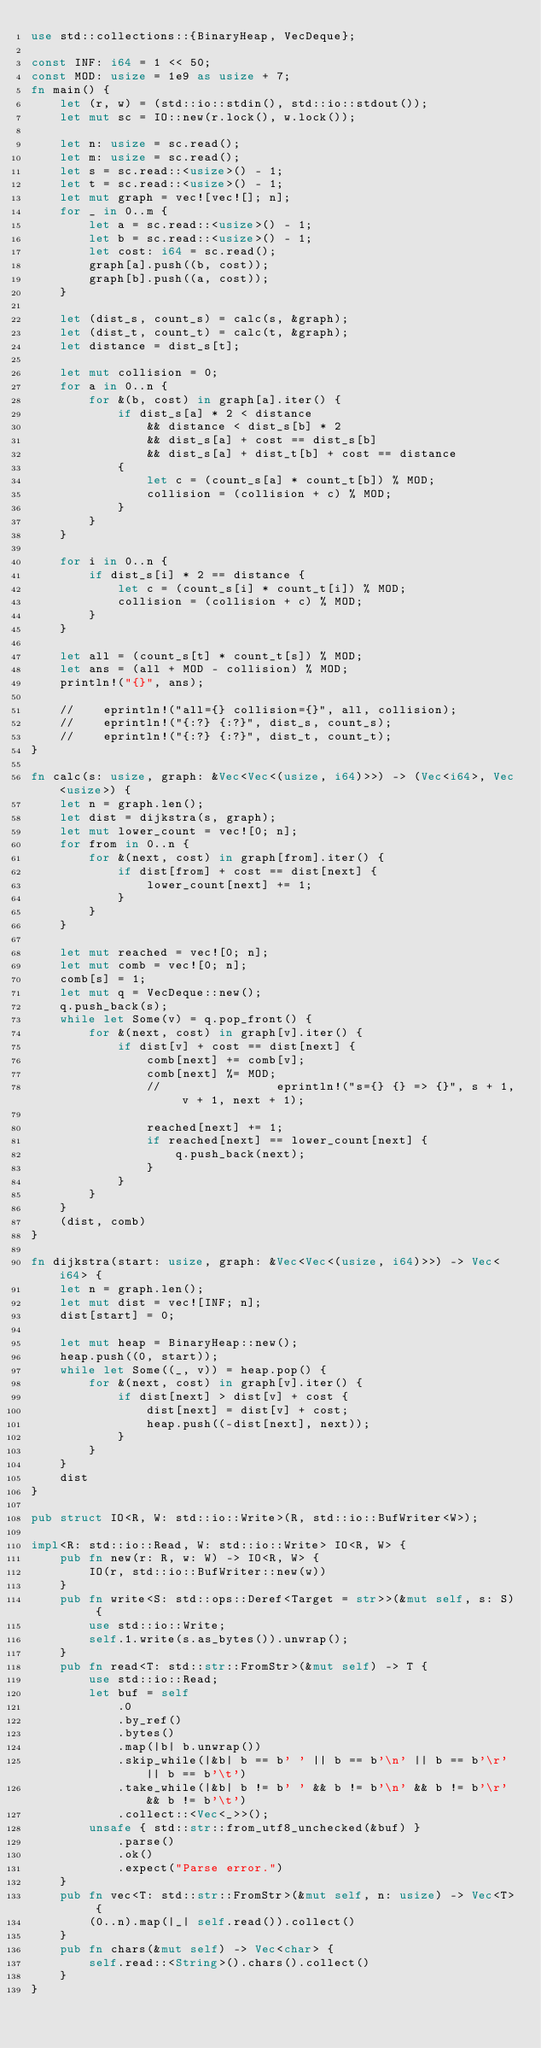<code> <loc_0><loc_0><loc_500><loc_500><_Rust_>use std::collections::{BinaryHeap, VecDeque};

const INF: i64 = 1 << 50;
const MOD: usize = 1e9 as usize + 7;
fn main() {
    let (r, w) = (std::io::stdin(), std::io::stdout());
    let mut sc = IO::new(r.lock(), w.lock());

    let n: usize = sc.read();
    let m: usize = sc.read();
    let s = sc.read::<usize>() - 1;
    let t = sc.read::<usize>() - 1;
    let mut graph = vec![vec![]; n];
    for _ in 0..m {
        let a = sc.read::<usize>() - 1;
        let b = sc.read::<usize>() - 1;
        let cost: i64 = sc.read();
        graph[a].push((b, cost));
        graph[b].push((a, cost));
    }

    let (dist_s, count_s) = calc(s, &graph);
    let (dist_t, count_t) = calc(t, &graph);
    let distance = dist_s[t];

    let mut collision = 0;
    for a in 0..n {
        for &(b, cost) in graph[a].iter() {
            if dist_s[a] * 2 < distance
                && distance < dist_s[b] * 2
                && dist_s[a] + cost == dist_s[b]
                && dist_s[a] + dist_t[b] + cost == distance
            {
                let c = (count_s[a] * count_t[b]) % MOD;
                collision = (collision + c) % MOD;
            }
        }
    }

    for i in 0..n {
        if dist_s[i] * 2 == distance {
            let c = (count_s[i] * count_t[i]) % MOD;
            collision = (collision + c) % MOD;
        }
    }

    let all = (count_s[t] * count_t[s]) % MOD;
    let ans = (all + MOD - collision) % MOD;
    println!("{}", ans);

    //    eprintln!("all={} collision={}", all, collision);
    //    eprintln!("{:?} {:?}", dist_s, count_s);
    //    eprintln!("{:?} {:?}", dist_t, count_t);
}

fn calc(s: usize, graph: &Vec<Vec<(usize, i64)>>) -> (Vec<i64>, Vec<usize>) {
    let n = graph.len();
    let dist = dijkstra(s, graph);
    let mut lower_count = vec![0; n];
    for from in 0..n {
        for &(next, cost) in graph[from].iter() {
            if dist[from] + cost == dist[next] {
                lower_count[next] += 1;
            }
        }
    }

    let mut reached = vec![0; n];
    let mut comb = vec![0; n];
    comb[s] = 1;
    let mut q = VecDeque::new();
    q.push_back(s);
    while let Some(v) = q.pop_front() {
        for &(next, cost) in graph[v].iter() {
            if dist[v] + cost == dist[next] {
                comb[next] += comb[v];
                comb[next] %= MOD;
                //                eprintln!("s={} {} => {}", s + 1, v + 1, next + 1);

                reached[next] += 1;
                if reached[next] == lower_count[next] {
                    q.push_back(next);
                }
            }
        }
    }
    (dist, comb)
}

fn dijkstra(start: usize, graph: &Vec<Vec<(usize, i64)>>) -> Vec<i64> {
    let n = graph.len();
    let mut dist = vec![INF; n];
    dist[start] = 0;

    let mut heap = BinaryHeap::new();
    heap.push((0, start));
    while let Some((_, v)) = heap.pop() {
        for &(next, cost) in graph[v].iter() {
            if dist[next] > dist[v] + cost {
                dist[next] = dist[v] + cost;
                heap.push((-dist[next], next));
            }
        }
    }
    dist
}

pub struct IO<R, W: std::io::Write>(R, std::io::BufWriter<W>);

impl<R: std::io::Read, W: std::io::Write> IO<R, W> {
    pub fn new(r: R, w: W) -> IO<R, W> {
        IO(r, std::io::BufWriter::new(w))
    }
    pub fn write<S: std::ops::Deref<Target = str>>(&mut self, s: S) {
        use std::io::Write;
        self.1.write(s.as_bytes()).unwrap();
    }
    pub fn read<T: std::str::FromStr>(&mut self) -> T {
        use std::io::Read;
        let buf = self
            .0
            .by_ref()
            .bytes()
            .map(|b| b.unwrap())
            .skip_while(|&b| b == b' ' || b == b'\n' || b == b'\r' || b == b'\t')
            .take_while(|&b| b != b' ' && b != b'\n' && b != b'\r' && b != b'\t')
            .collect::<Vec<_>>();
        unsafe { std::str::from_utf8_unchecked(&buf) }
            .parse()
            .ok()
            .expect("Parse error.")
    }
    pub fn vec<T: std::str::FromStr>(&mut self, n: usize) -> Vec<T> {
        (0..n).map(|_| self.read()).collect()
    }
    pub fn chars(&mut self) -> Vec<char> {
        self.read::<String>().chars().collect()
    }
}
</code> 